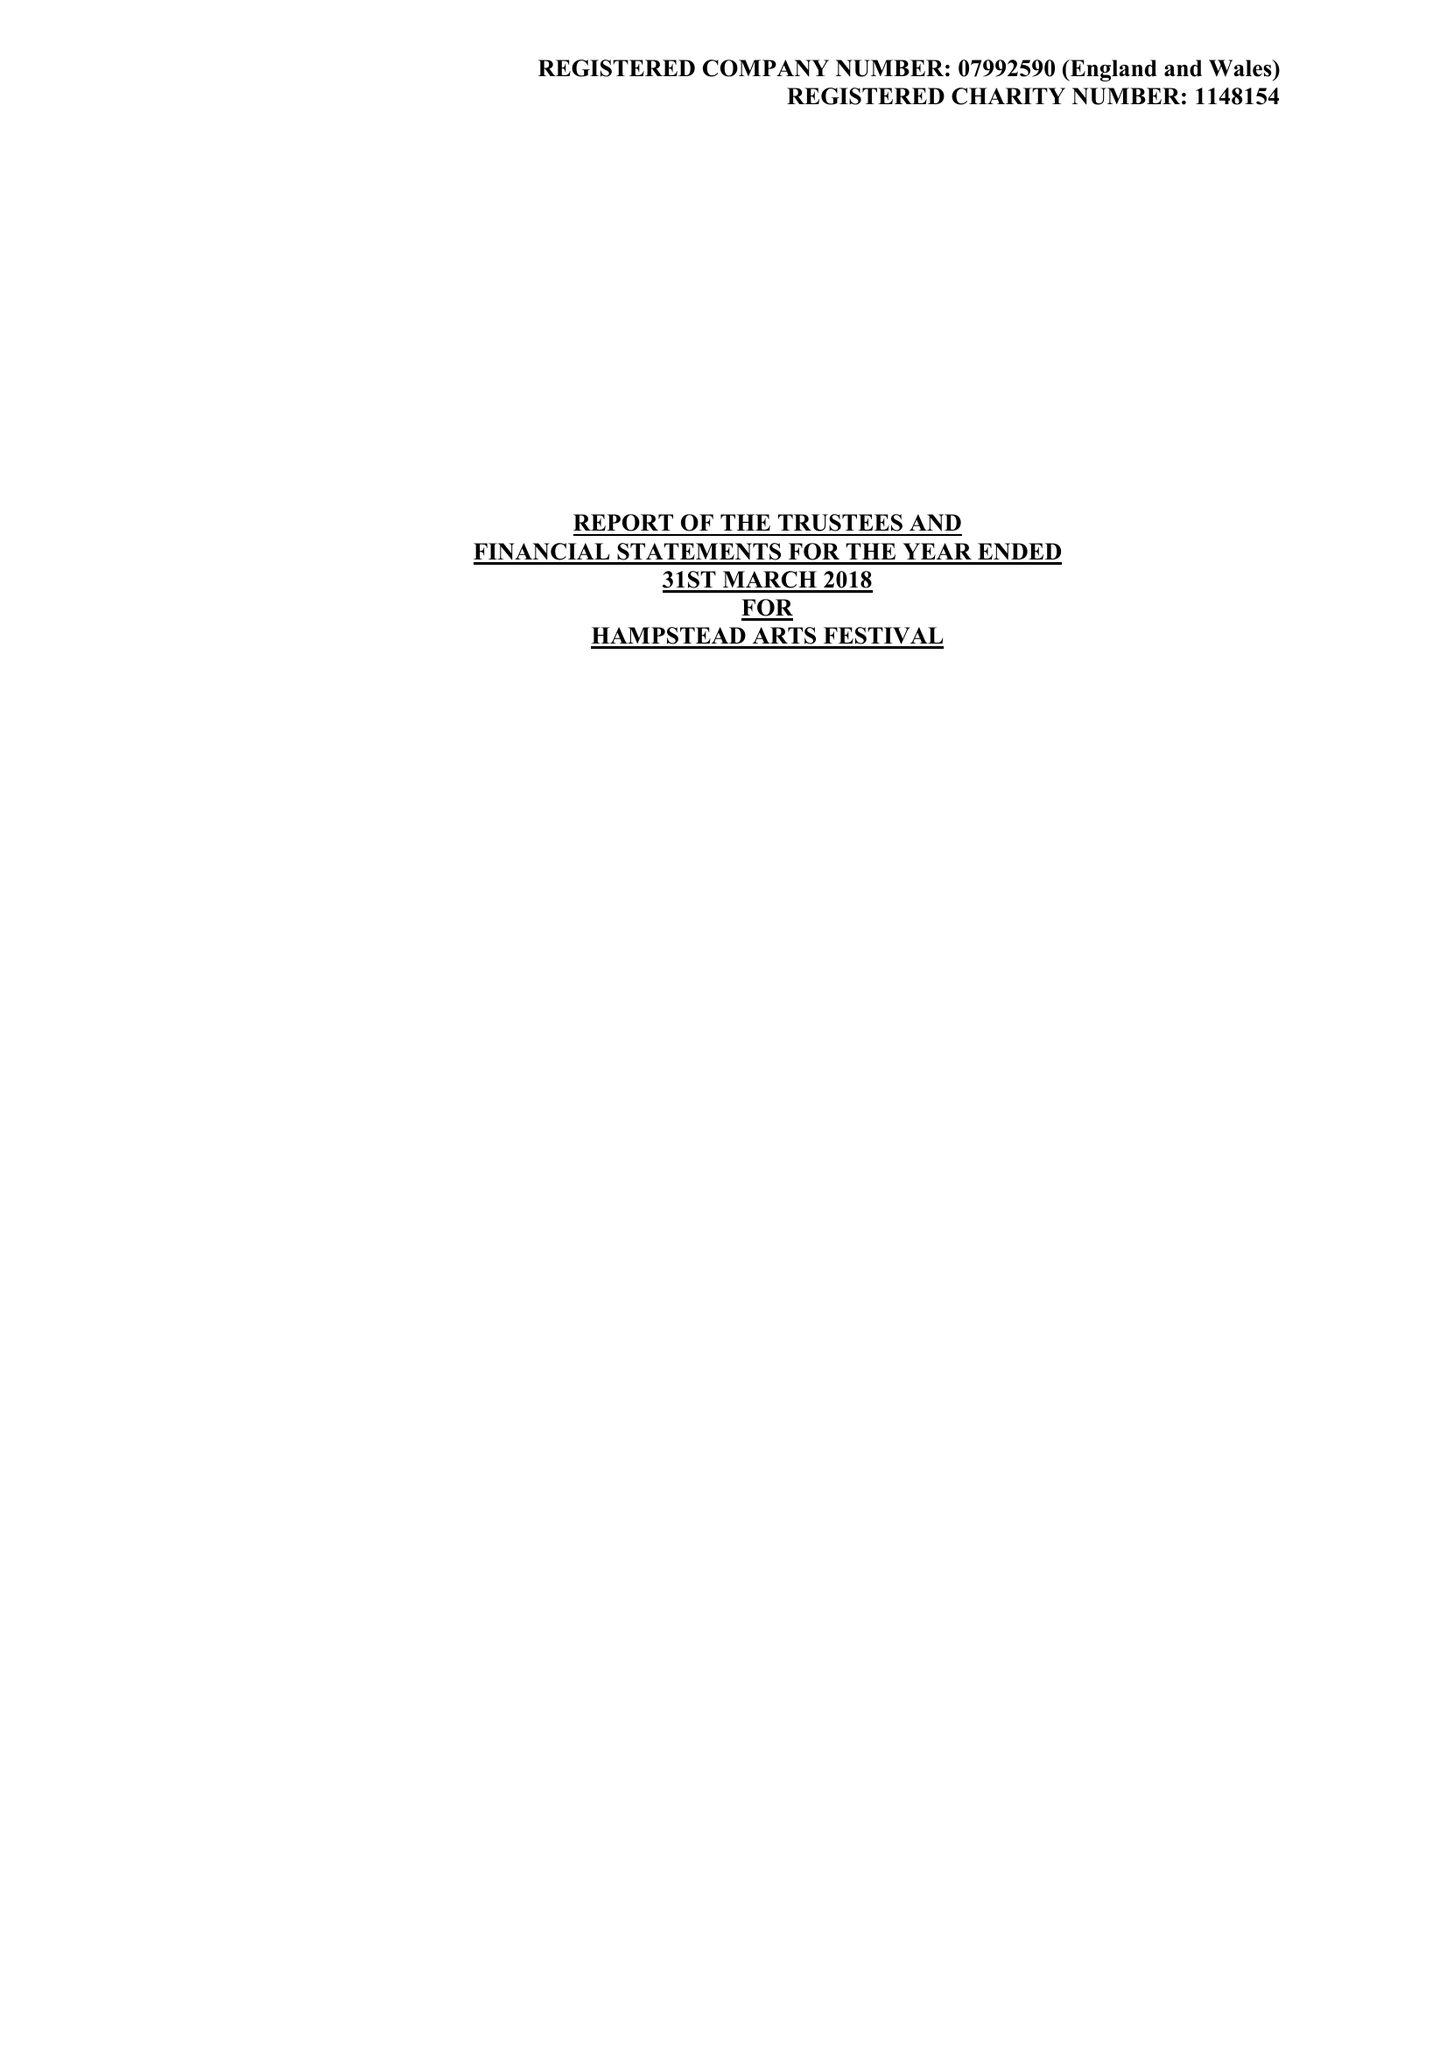What is the value for the income_annually_in_british_pounds?
Answer the question using a single word or phrase. 44520.00 